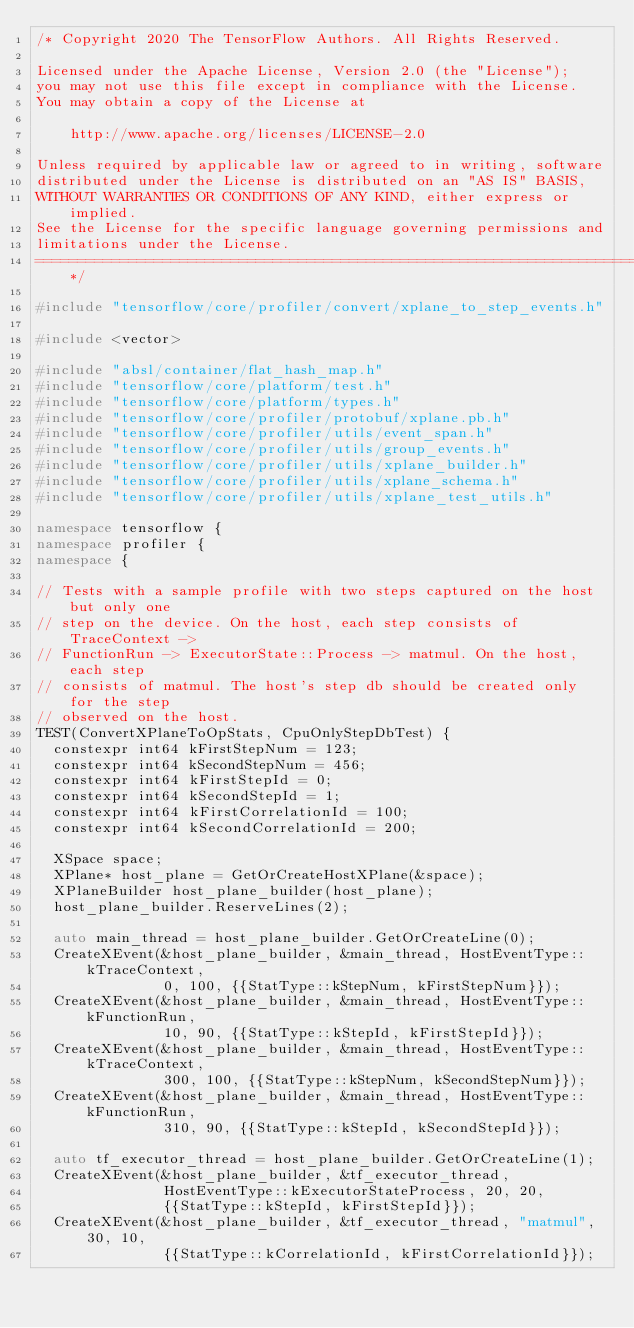Convert code to text. <code><loc_0><loc_0><loc_500><loc_500><_C++_>/* Copyright 2020 The TensorFlow Authors. All Rights Reserved.

Licensed under the Apache License, Version 2.0 (the "License");
you may not use this file except in compliance with the License.
You may obtain a copy of the License at

    http://www.apache.org/licenses/LICENSE-2.0

Unless required by applicable law or agreed to in writing, software
distributed under the License is distributed on an "AS IS" BASIS,
WITHOUT WARRANTIES OR CONDITIONS OF ANY KIND, either express or implied.
See the License for the specific language governing permissions and
limitations under the License.
==============================================================================*/

#include "tensorflow/core/profiler/convert/xplane_to_step_events.h"

#include <vector>

#include "absl/container/flat_hash_map.h"
#include "tensorflow/core/platform/test.h"
#include "tensorflow/core/platform/types.h"
#include "tensorflow/core/profiler/protobuf/xplane.pb.h"
#include "tensorflow/core/profiler/utils/event_span.h"
#include "tensorflow/core/profiler/utils/group_events.h"
#include "tensorflow/core/profiler/utils/xplane_builder.h"
#include "tensorflow/core/profiler/utils/xplane_schema.h"
#include "tensorflow/core/profiler/utils/xplane_test_utils.h"

namespace tensorflow {
namespace profiler {
namespace {

// Tests with a sample profile with two steps captured on the host but only one
// step on the device. On the host, each step consists of TraceContext ->
// FunctionRun -> ExecutorState::Process -> matmul. On the host, each step
// consists of matmul. The host's step db should be created only for the step
// observed on the host.
TEST(ConvertXPlaneToOpStats, CpuOnlyStepDbTest) {
  constexpr int64 kFirstStepNum = 123;
  constexpr int64 kSecondStepNum = 456;
  constexpr int64 kFirstStepId = 0;
  constexpr int64 kSecondStepId = 1;
  constexpr int64 kFirstCorrelationId = 100;
  constexpr int64 kSecondCorrelationId = 200;

  XSpace space;
  XPlane* host_plane = GetOrCreateHostXPlane(&space);
  XPlaneBuilder host_plane_builder(host_plane);
  host_plane_builder.ReserveLines(2);

  auto main_thread = host_plane_builder.GetOrCreateLine(0);
  CreateXEvent(&host_plane_builder, &main_thread, HostEventType::kTraceContext,
               0, 100, {{StatType::kStepNum, kFirstStepNum}});
  CreateXEvent(&host_plane_builder, &main_thread, HostEventType::kFunctionRun,
               10, 90, {{StatType::kStepId, kFirstStepId}});
  CreateXEvent(&host_plane_builder, &main_thread, HostEventType::kTraceContext,
               300, 100, {{StatType::kStepNum, kSecondStepNum}});
  CreateXEvent(&host_plane_builder, &main_thread, HostEventType::kFunctionRun,
               310, 90, {{StatType::kStepId, kSecondStepId}});

  auto tf_executor_thread = host_plane_builder.GetOrCreateLine(1);
  CreateXEvent(&host_plane_builder, &tf_executor_thread,
               HostEventType::kExecutorStateProcess, 20, 20,
               {{StatType::kStepId, kFirstStepId}});
  CreateXEvent(&host_plane_builder, &tf_executor_thread, "matmul", 30, 10,
               {{StatType::kCorrelationId, kFirstCorrelationId}});</code> 